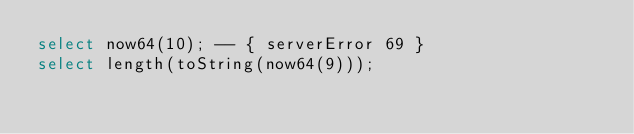<code> <loc_0><loc_0><loc_500><loc_500><_SQL_>select now64(10); -- { serverError 69 }
select length(toString(now64(9)));
</code> 